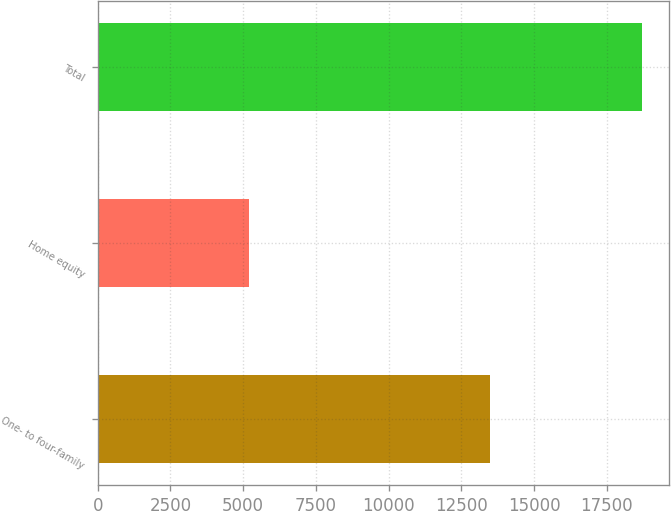Convert chart. <chart><loc_0><loc_0><loc_500><loc_500><bar_chart><fcel>One- to four-family<fcel>Home equity<fcel>Total<nl><fcel>13498<fcel>5209<fcel>18707<nl></chart> 